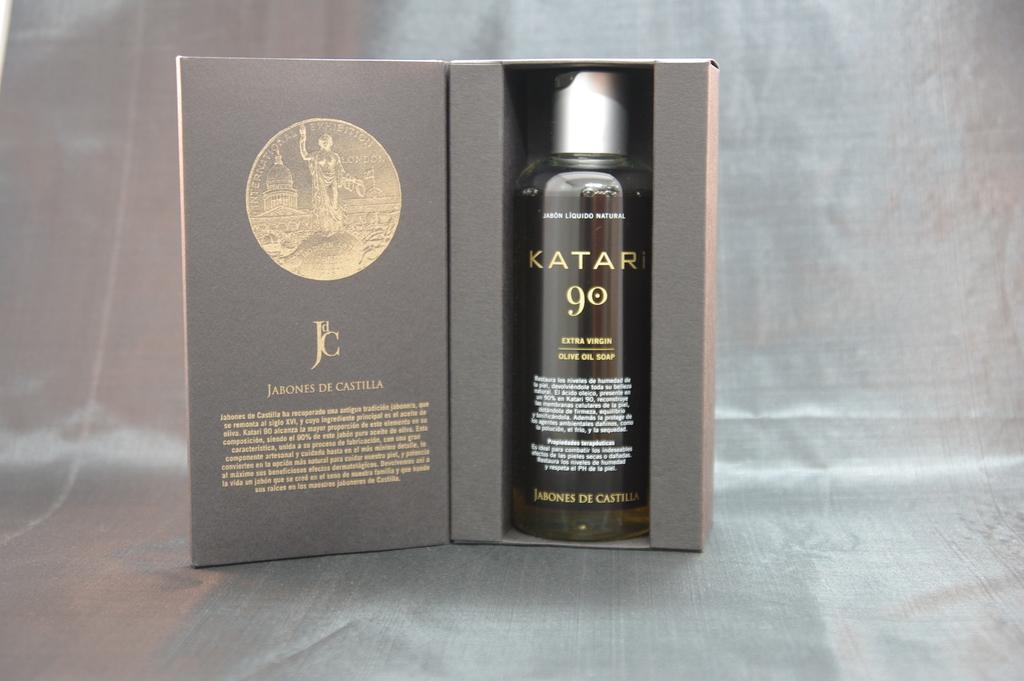What is the name of the product?
Provide a succinct answer. Katari. 